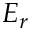<formula> <loc_0><loc_0><loc_500><loc_500>E _ { r }</formula> 